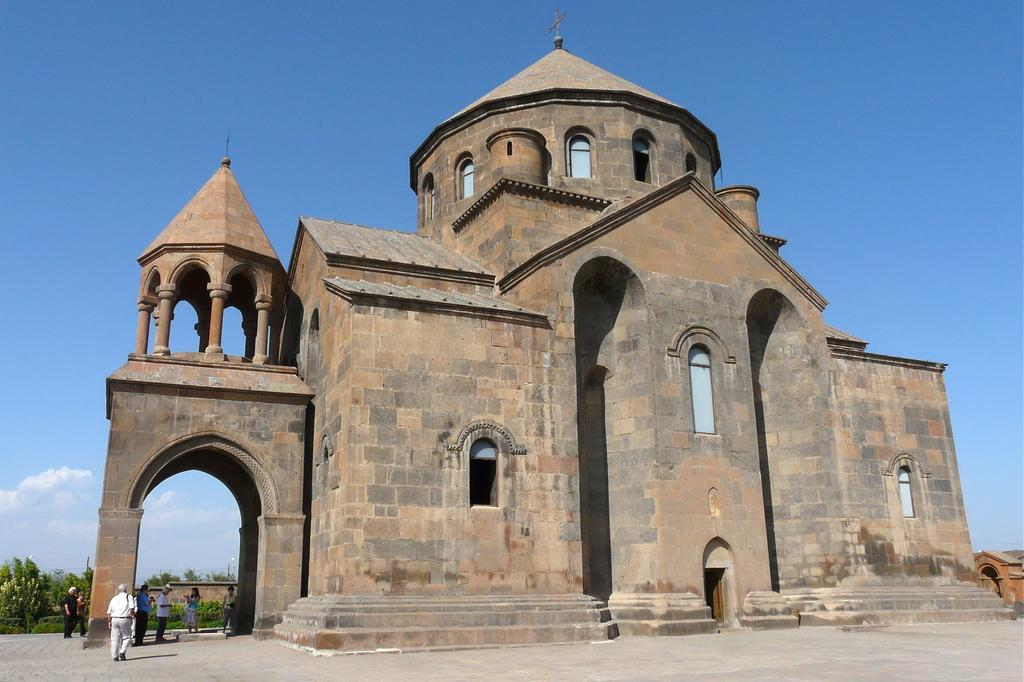What type of structures can be seen in the image? There are buildings in the image. What other natural elements are present in the image? There are trees in the image. Are there any living beings visible in the image? Yes, there are people standing in the image. What can be seen in the background of the image? There are clouds and the sky visible in the background of the image. How many rabbits can be seen hopping through the fog in the image? There are no rabbits or fog present in the image. 